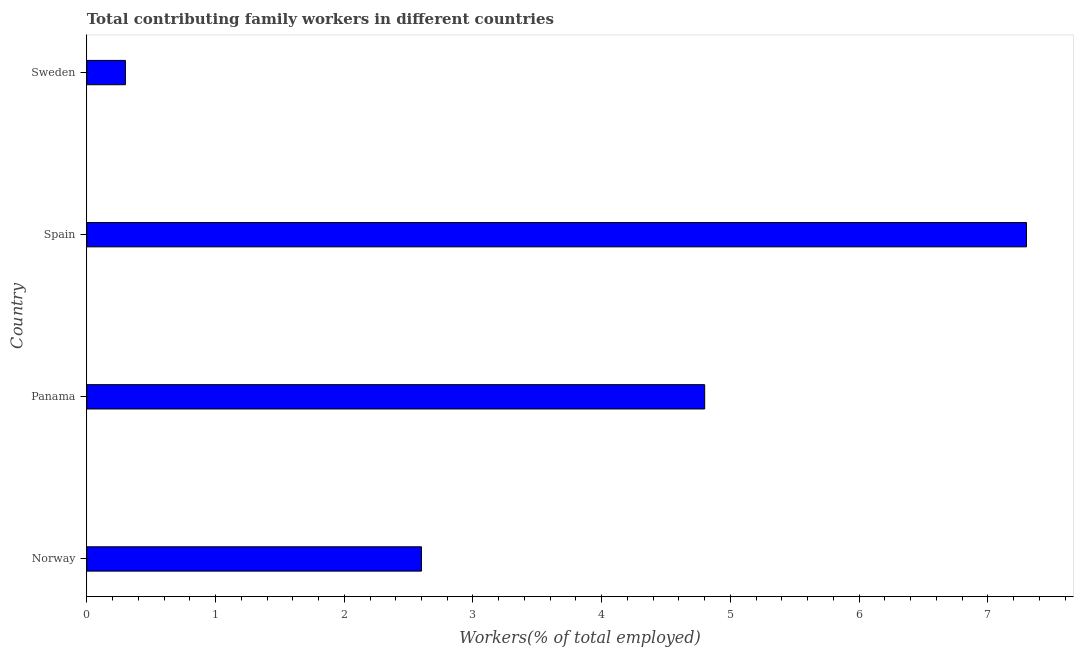What is the title of the graph?
Offer a very short reply. Total contributing family workers in different countries. What is the label or title of the X-axis?
Your answer should be very brief. Workers(% of total employed). What is the contributing family workers in Sweden?
Keep it short and to the point. 0.3. Across all countries, what is the maximum contributing family workers?
Provide a succinct answer. 7.3. Across all countries, what is the minimum contributing family workers?
Provide a short and direct response. 0.3. In which country was the contributing family workers maximum?
Offer a terse response. Spain. In which country was the contributing family workers minimum?
Give a very brief answer. Sweden. What is the sum of the contributing family workers?
Your answer should be very brief. 15. What is the average contributing family workers per country?
Offer a very short reply. 3.75. What is the median contributing family workers?
Provide a succinct answer. 3.7. What is the ratio of the contributing family workers in Norway to that in Spain?
Keep it short and to the point. 0.36. Is the difference between the contributing family workers in Panama and Spain greater than the difference between any two countries?
Your answer should be compact. No. What is the difference between the highest and the second highest contributing family workers?
Offer a terse response. 2.5. Is the sum of the contributing family workers in Norway and Sweden greater than the maximum contributing family workers across all countries?
Give a very brief answer. No. Are all the bars in the graph horizontal?
Make the answer very short. Yes. How many countries are there in the graph?
Ensure brevity in your answer.  4. What is the difference between two consecutive major ticks on the X-axis?
Offer a terse response. 1. What is the Workers(% of total employed) of Norway?
Offer a very short reply. 2.6. What is the Workers(% of total employed) in Panama?
Your answer should be compact. 4.8. What is the Workers(% of total employed) of Spain?
Give a very brief answer. 7.3. What is the Workers(% of total employed) of Sweden?
Your response must be concise. 0.3. What is the difference between the Workers(% of total employed) in Panama and Sweden?
Your answer should be compact. 4.5. What is the difference between the Workers(% of total employed) in Spain and Sweden?
Give a very brief answer. 7. What is the ratio of the Workers(% of total employed) in Norway to that in Panama?
Offer a very short reply. 0.54. What is the ratio of the Workers(% of total employed) in Norway to that in Spain?
Your answer should be compact. 0.36. What is the ratio of the Workers(% of total employed) in Norway to that in Sweden?
Provide a succinct answer. 8.67. What is the ratio of the Workers(% of total employed) in Panama to that in Spain?
Keep it short and to the point. 0.66. What is the ratio of the Workers(% of total employed) in Spain to that in Sweden?
Make the answer very short. 24.33. 